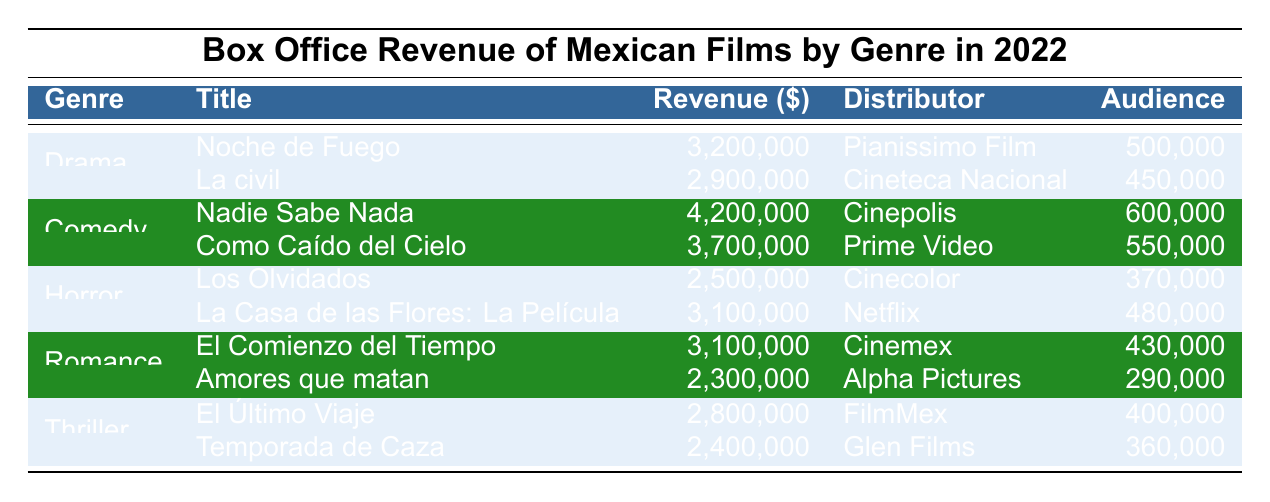What is the highest-grossing comedy film in 2022? The table shows that the highest-grossing comedy film is "Nadie Sabe Nada," with a revenue of $4,200,000.
Answer: Nadie Sabe Nada Which genre had the least audience in total? To find this, we add the audiences from all movies in each genre. Drama: 500,000 + 450,000 = 950,000; Comedy: 600,000 + 550,000 = 1,150,000; Horror: 370,000 + 480,000 = 850,000; Romance: 430,000 + 290,000 = 720,000; Thriller: 400,000 + 360,000 = 760,000. The least audience is in Romance with 720,000.
Answer: Romance How much revenue did horror films generate in total? The revenue for horror films is $2,500,000 from "Los Olvidados" and $3,100,000 from "La Casa de las Flores: La Película." Adding these gives $2,500,000 + $3,100,000 = $5,600,000 total revenue for horror films.
Answer: $5,600,000 Is "Amores que matan" more popular than "El Comienzo del Tiempo" based on audience numbers? "Amores que matan" has an audience of 290,000, while "El Comienzo del Tiempo" has 430,000. Since 290,000 is less than 430,000, "Amores que matan" is not more popular.
Answer: No What is the average revenue of thriller films? The total revenue for thriller films is $2,800,000 + $2,400,000 = $5,200,000. There are two thriller films, so the average revenue is $5,200,000 / 2 = $2,600,000.
Answer: $2,600,000 Which movie had the highest revenue among all films in the table? Across all genres, "Nadie Sabe Nada" has the highest revenue of $4,200,000.
Answer: Nadie Sabe Nada If we combine the total revenue from drama and comedy, what is the figure? The total revenue for drama is $3,200,000 + $2,900,000 = $6,100,000 and for comedy is $4,200,000 + $3,700,000 = $7,900,000. Adding both totals gives $6,100,000 + $7,900,000 = $14,000,000.
Answer: $14,000,000 How many more people attended "La civil" compared to "Los Olvidados"? "La civil" had an audience of 450,000, while "Los Olvidados" had 370,000. The difference in audience is 450,000 - 370,000 = 80,000.
Answer: 80,000 What percentage of the total audience does “Nadie Sabe Nada” represent? The total audience across all genres is 950,000 + 1,150,000 + 850,000 + 720,000 + 760,000 = 3,430,000. "Nadie Sabe Nada" had 600,000 viewers. The percentage is (600,000 / 3,430,000) * 100 ≈ 17.5%.
Answer: 17.5% Which genre had the highest individual film revenue? "Nadie Sabe Nada" from comedy had the highest revenue of $4,200,000. No other film generated more revenue than this in the table.
Answer: Comedy 